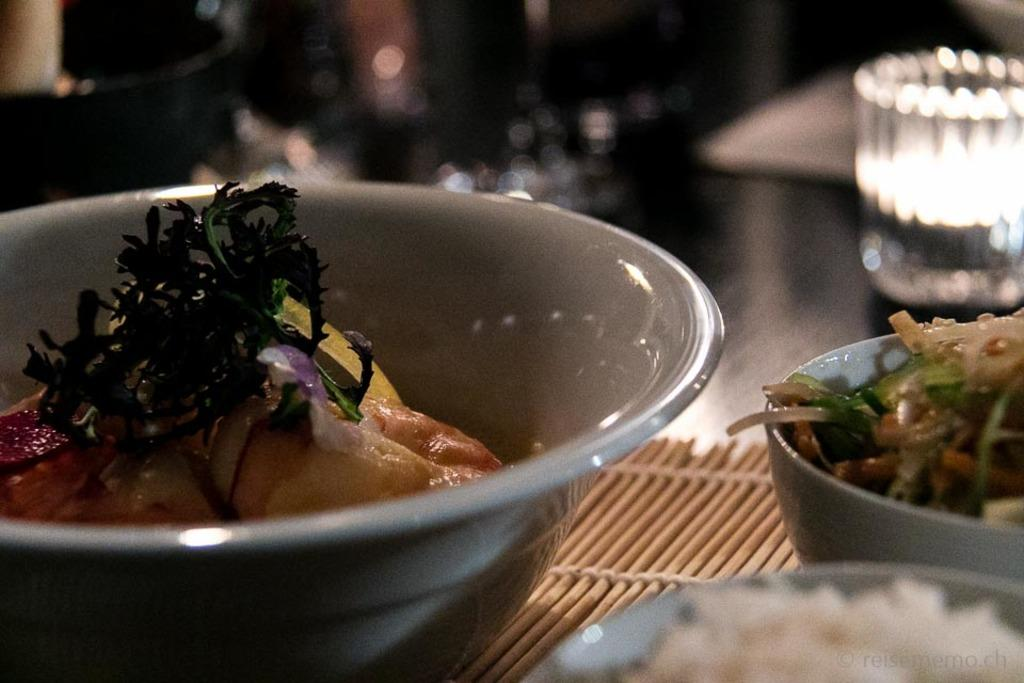How many bowls containing food can be seen in the image? There are three bowls containing food in the image. Where are the bowls located in the image? The bowls are placed on a surface in the foreground. Can you describe anything visible in the background of the image? Yes, there is a glass visible in the background of the image. What is the interest rate of the loan mentioned in the image? There is no mention of a loan or interest rate in the image; it only contains three bowls containing food and a glass in the background. 